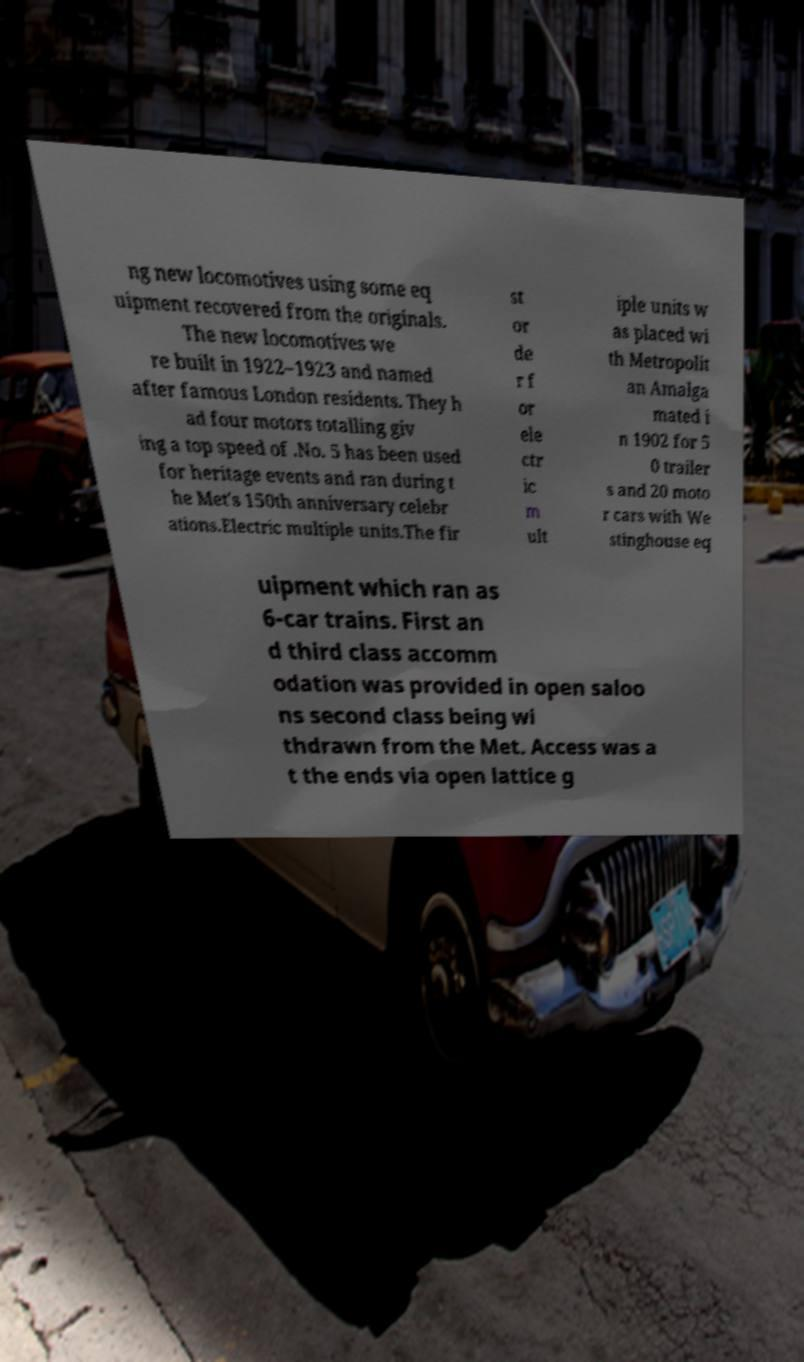What messages or text are displayed in this image? I need them in a readable, typed format. ng new locomotives using some eq uipment recovered from the originals. The new locomotives we re built in 1922–1923 and named after famous London residents. They h ad four motors totalling giv ing a top speed of .No. 5 has been used for heritage events and ran during t he Met's 150th anniversary celebr ations.Electric multiple units.The fir st or de r f or ele ctr ic m ult iple units w as placed wi th Metropolit an Amalga mated i n 1902 for 5 0 trailer s and 20 moto r cars with We stinghouse eq uipment which ran as 6-car trains. First an d third class accomm odation was provided in open saloo ns second class being wi thdrawn from the Met. Access was a t the ends via open lattice g 